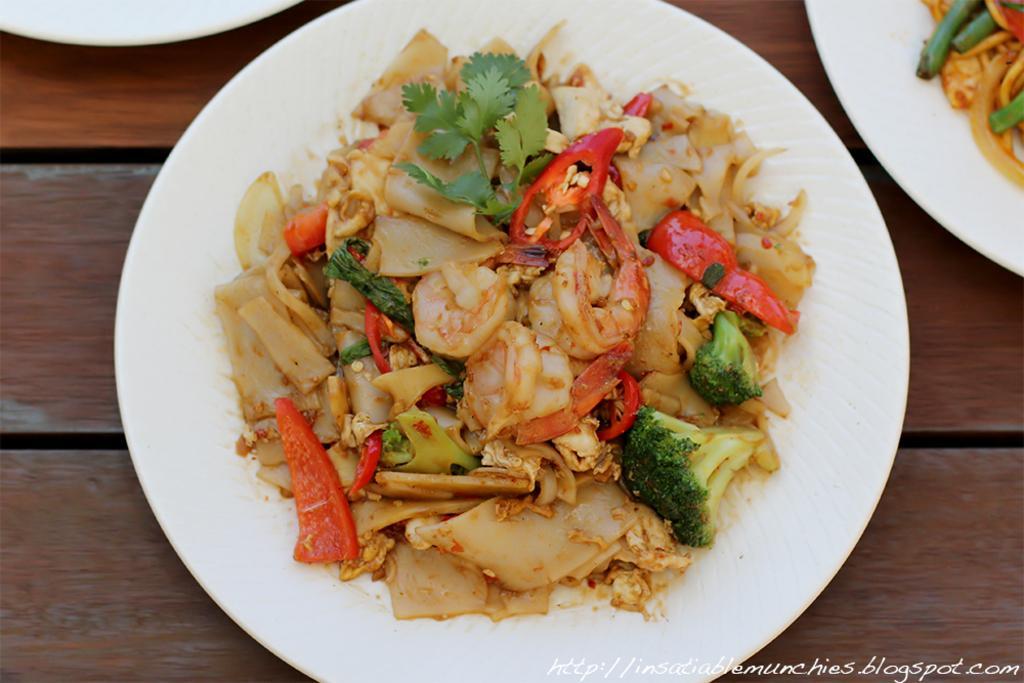Could you give a brief overview of what you see in this image? In this image there is a table on which there is pasta. On the pasta there are tomato pieces,broccoli leaves,coriander and chilli pieces. On the right side top corner there is another plate on which there is food. The plate is kept on the table. 